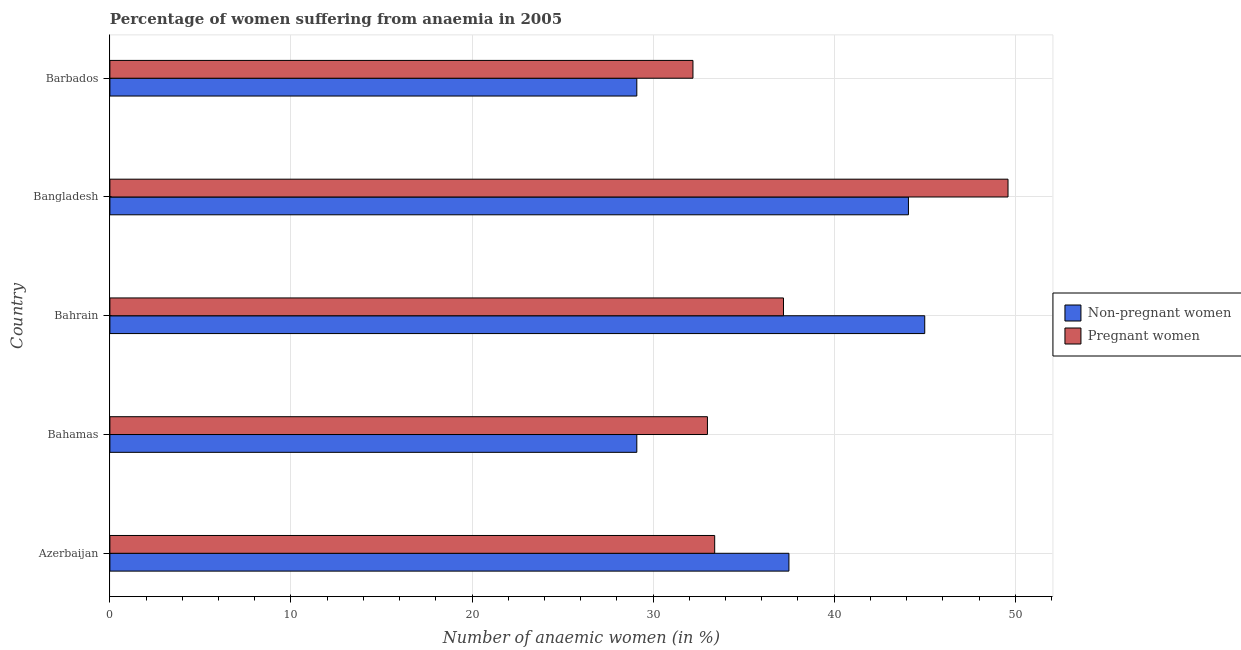How many different coloured bars are there?
Offer a very short reply. 2. Are the number of bars per tick equal to the number of legend labels?
Give a very brief answer. Yes. Are the number of bars on each tick of the Y-axis equal?
Provide a succinct answer. Yes. How many bars are there on the 5th tick from the top?
Give a very brief answer. 2. How many bars are there on the 5th tick from the bottom?
Ensure brevity in your answer.  2. What is the label of the 3rd group of bars from the top?
Provide a short and direct response. Bahrain. In how many cases, is the number of bars for a given country not equal to the number of legend labels?
Make the answer very short. 0. What is the percentage of pregnant anaemic women in Bangladesh?
Your answer should be compact. 49.6. Across all countries, what is the minimum percentage of non-pregnant anaemic women?
Ensure brevity in your answer.  29.1. In which country was the percentage of pregnant anaemic women maximum?
Ensure brevity in your answer.  Bangladesh. In which country was the percentage of non-pregnant anaemic women minimum?
Your response must be concise. Bahamas. What is the total percentage of pregnant anaemic women in the graph?
Your response must be concise. 185.4. What is the difference between the percentage of non-pregnant anaemic women in Bahrain and the percentage of pregnant anaemic women in Barbados?
Provide a succinct answer. 12.8. What is the average percentage of non-pregnant anaemic women per country?
Give a very brief answer. 36.96. What is the ratio of the percentage of non-pregnant anaemic women in Bahrain to that in Barbados?
Keep it short and to the point. 1.55. Is the percentage of pregnant anaemic women in Azerbaijan less than that in Bahamas?
Provide a succinct answer. No. Is the difference between the percentage of non-pregnant anaemic women in Bahamas and Barbados greater than the difference between the percentage of pregnant anaemic women in Bahamas and Barbados?
Provide a succinct answer. No. What is the difference between the highest and the second highest percentage of pregnant anaemic women?
Make the answer very short. 12.4. In how many countries, is the percentage of pregnant anaemic women greater than the average percentage of pregnant anaemic women taken over all countries?
Offer a terse response. 2. Is the sum of the percentage of non-pregnant anaemic women in Azerbaijan and Bangladesh greater than the maximum percentage of pregnant anaemic women across all countries?
Make the answer very short. Yes. What does the 1st bar from the top in Barbados represents?
Keep it short and to the point. Pregnant women. What does the 1st bar from the bottom in Bangladesh represents?
Offer a very short reply. Non-pregnant women. How many bars are there?
Provide a short and direct response. 10. What is the difference between two consecutive major ticks on the X-axis?
Your answer should be compact. 10. Are the values on the major ticks of X-axis written in scientific E-notation?
Offer a very short reply. No. Does the graph contain grids?
Provide a short and direct response. Yes. Where does the legend appear in the graph?
Provide a short and direct response. Center right. What is the title of the graph?
Ensure brevity in your answer.  Percentage of women suffering from anaemia in 2005. What is the label or title of the X-axis?
Provide a short and direct response. Number of anaemic women (in %). What is the Number of anaemic women (in %) in Non-pregnant women in Azerbaijan?
Your answer should be compact. 37.5. What is the Number of anaemic women (in %) of Pregnant women in Azerbaijan?
Your response must be concise. 33.4. What is the Number of anaemic women (in %) of Non-pregnant women in Bahamas?
Provide a short and direct response. 29.1. What is the Number of anaemic women (in %) in Pregnant women in Bahamas?
Your response must be concise. 33. What is the Number of anaemic women (in %) of Non-pregnant women in Bahrain?
Your answer should be very brief. 45. What is the Number of anaemic women (in %) of Pregnant women in Bahrain?
Keep it short and to the point. 37.2. What is the Number of anaemic women (in %) of Non-pregnant women in Bangladesh?
Offer a very short reply. 44.1. What is the Number of anaemic women (in %) in Pregnant women in Bangladesh?
Offer a terse response. 49.6. What is the Number of anaemic women (in %) of Non-pregnant women in Barbados?
Give a very brief answer. 29.1. What is the Number of anaemic women (in %) of Pregnant women in Barbados?
Your answer should be compact. 32.2. Across all countries, what is the maximum Number of anaemic women (in %) of Pregnant women?
Offer a terse response. 49.6. Across all countries, what is the minimum Number of anaemic women (in %) of Non-pregnant women?
Provide a short and direct response. 29.1. Across all countries, what is the minimum Number of anaemic women (in %) of Pregnant women?
Make the answer very short. 32.2. What is the total Number of anaemic women (in %) of Non-pregnant women in the graph?
Make the answer very short. 184.8. What is the total Number of anaemic women (in %) in Pregnant women in the graph?
Keep it short and to the point. 185.4. What is the difference between the Number of anaemic women (in %) of Non-pregnant women in Azerbaijan and that in Bahrain?
Ensure brevity in your answer.  -7.5. What is the difference between the Number of anaemic women (in %) in Pregnant women in Azerbaijan and that in Bahrain?
Give a very brief answer. -3.8. What is the difference between the Number of anaemic women (in %) in Pregnant women in Azerbaijan and that in Bangladesh?
Offer a terse response. -16.2. What is the difference between the Number of anaemic women (in %) in Pregnant women in Azerbaijan and that in Barbados?
Make the answer very short. 1.2. What is the difference between the Number of anaemic women (in %) of Non-pregnant women in Bahamas and that in Bahrain?
Your response must be concise. -15.9. What is the difference between the Number of anaemic women (in %) of Pregnant women in Bahamas and that in Bahrain?
Provide a succinct answer. -4.2. What is the difference between the Number of anaemic women (in %) in Pregnant women in Bahamas and that in Bangladesh?
Your answer should be very brief. -16.6. What is the difference between the Number of anaemic women (in %) of Pregnant women in Bahamas and that in Barbados?
Offer a terse response. 0.8. What is the difference between the Number of anaemic women (in %) in Pregnant women in Bahrain and that in Bangladesh?
Make the answer very short. -12.4. What is the difference between the Number of anaemic women (in %) of Non-pregnant women in Bahrain and that in Barbados?
Offer a terse response. 15.9. What is the difference between the Number of anaemic women (in %) of Pregnant women in Bahrain and that in Barbados?
Your response must be concise. 5. What is the difference between the Number of anaemic women (in %) in Non-pregnant women in Bangladesh and that in Barbados?
Your answer should be very brief. 15. What is the difference between the Number of anaemic women (in %) in Pregnant women in Bangladesh and that in Barbados?
Provide a succinct answer. 17.4. What is the difference between the Number of anaemic women (in %) in Non-pregnant women in Azerbaijan and the Number of anaemic women (in %) in Pregnant women in Bahamas?
Your answer should be very brief. 4.5. What is the difference between the Number of anaemic women (in %) of Non-pregnant women in Azerbaijan and the Number of anaemic women (in %) of Pregnant women in Bangladesh?
Make the answer very short. -12.1. What is the difference between the Number of anaemic women (in %) of Non-pregnant women in Azerbaijan and the Number of anaemic women (in %) of Pregnant women in Barbados?
Keep it short and to the point. 5.3. What is the difference between the Number of anaemic women (in %) in Non-pregnant women in Bahamas and the Number of anaemic women (in %) in Pregnant women in Bangladesh?
Offer a terse response. -20.5. What is the difference between the Number of anaemic women (in %) in Non-pregnant women in Bahamas and the Number of anaemic women (in %) in Pregnant women in Barbados?
Offer a very short reply. -3.1. What is the difference between the Number of anaemic women (in %) of Non-pregnant women in Bangladesh and the Number of anaemic women (in %) of Pregnant women in Barbados?
Make the answer very short. 11.9. What is the average Number of anaemic women (in %) in Non-pregnant women per country?
Offer a terse response. 36.96. What is the average Number of anaemic women (in %) of Pregnant women per country?
Keep it short and to the point. 37.08. What is the difference between the Number of anaemic women (in %) in Non-pregnant women and Number of anaemic women (in %) in Pregnant women in Bahrain?
Keep it short and to the point. 7.8. What is the difference between the Number of anaemic women (in %) of Non-pregnant women and Number of anaemic women (in %) of Pregnant women in Bangladesh?
Provide a succinct answer. -5.5. What is the ratio of the Number of anaemic women (in %) of Non-pregnant women in Azerbaijan to that in Bahamas?
Make the answer very short. 1.29. What is the ratio of the Number of anaemic women (in %) of Pregnant women in Azerbaijan to that in Bahamas?
Offer a very short reply. 1.01. What is the ratio of the Number of anaemic women (in %) in Non-pregnant women in Azerbaijan to that in Bahrain?
Offer a terse response. 0.83. What is the ratio of the Number of anaemic women (in %) in Pregnant women in Azerbaijan to that in Bahrain?
Provide a short and direct response. 0.9. What is the ratio of the Number of anaemic women (in %) in Non-pregnant women in Azerbaijan to that in Bangladesh?
Ensure brevity in your answer.  0.85. What is the ratio of the Number of anaemic women (in %) of Pregnant women in Azerbaijan to that in Bangladesh?
Your answer should be compact. 0.67. What is the ratio of the Number of anaemic women (in %) of Non-pregnant women in Azerbaijan to that in Barbados?
Make the answer very short. 1.29. What is the ratio of the Number of anaemic women (in %) in Pregnant women in Azerbaijan to that in Barbados?
Your answer should be compact. 1.04. What is the ratio of the Number of anaemic women (in %) of Non-pregnant women in Bahamas to that in Bahrain?
Your answer should be compact. 0.65. What is the ratio of the Number of anaemic women (in %) of Pregnant women in Bahamas to that in Bahrain?
Provide a succinct answer. 0.89. What is the ratio of the Number of anaemic women (in %) of Non-pregnant women in Bahamas to that in Bangladesh?
Keep it short and to the point. 0.66. What is the ratio of the Number of anaemic women (in %) of Pregnant women in Bahamas to that in Bangladesh?
Your answer should be compact. 0.67. What is the ratio of the Number of anaemic women (in %) of Pregnant women in Bahamas to that in Barbados?
Offer a very short reply. 1.02. What is the ratio of the Number of anaemic women (in %) of Non-pregnant women in Bahrain to that in Bangladesh?
Give a very brief answer. 1.02. What is the ratio of the Number of anaemic women (in %) of Non-pregnant women in Bahrain to that in Barbados?
Provide a short and direct response. 1.55. What is the ratio of the Number of anaemic women (in %) of Pregnant women in Bahrain to that in Barbados?
Offer a very short reply. 1.16. What is the ratio of the Number of anaemic women (in %) of Non-pregnant women in Bangladesh to that in Barbados?
Your answer should be compact. 1.52. What is the ratio of the Number of anaemic women (in %) in Pregnant women in Bangladesh to that in Barbados?
Keep it short and to the point. 1.54. What is the difference between the highest and the second highest Number of anaemic women (in %) in Non-pregnant women?
Provide a succinct answer. 0.9. What is the difference between the highest and the lowest Number of anaemic women (in %) of Pregnant women?
Offer a very short reply. 17.4. 